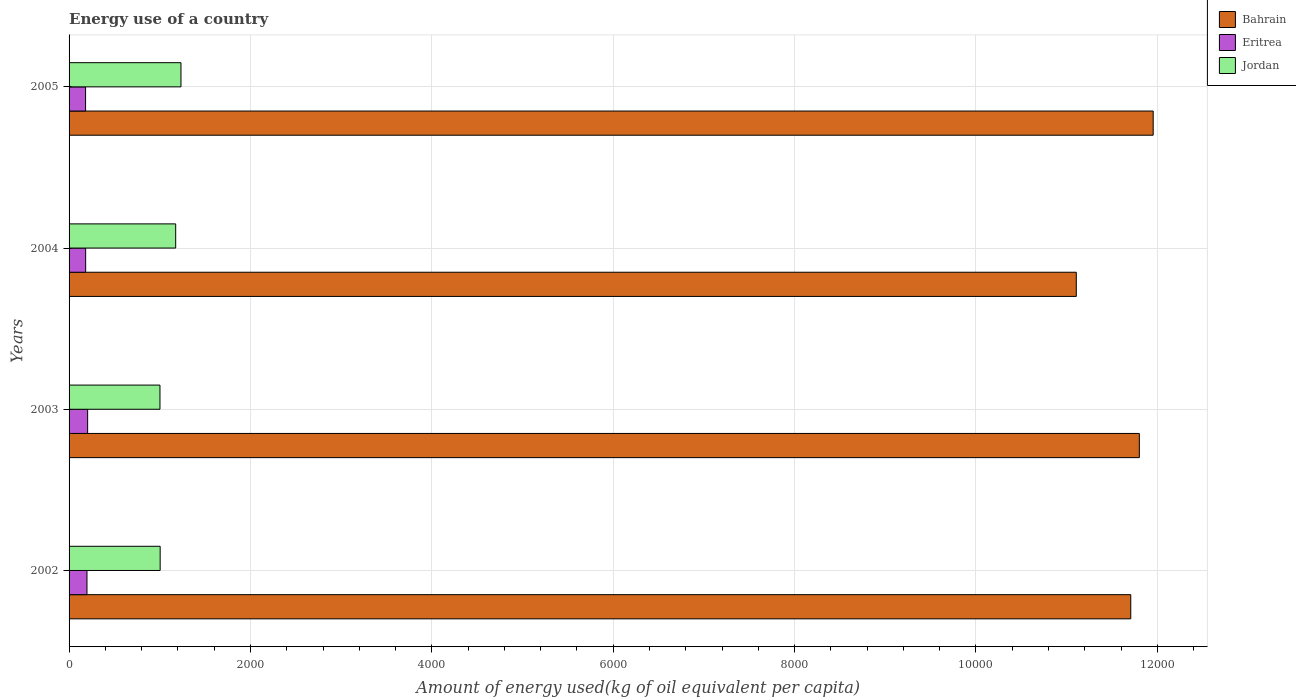How many groups of bars are there?
Your response must be concise. 4. Are the number of bars per tick equal to the number of legend labels?
Make the answer very short. Yes. Are the number of bars on each tick of the Y-axis equal?
Provide a succinct answer. Yes. How many bars are there on the 2nd tick from the bottom?
Make the answer very short. 3. What is the amount of energy used in in Bahrain in 2005?
Provide a short and direct response. 1.20e+04. Across all years, what is the maximum amount of energy used in in Jordan?
Your response must be concise. 1233.95. Across all years, what is the minimum amount of energy used in in Eritrea?
Your answer should be compact. 182.02. In which year was the amount of energy used in in Bahrain minimum?
Make the answer very short. 2004. What is the total amount of energy used in in Eritrea in the graph?
Your response must be concise. 767.22. What is the difference between the amount of energy used in in Eritrea in 2002 and that in 2005?
Offer a very short reply. 15.53. What is the difference between the amount of energy used in in Eritrea in 2004 and the amount of energy used in in Bahrain in 2003?
Offer a very short reply. -1.16e+04. What is the average amount of energy used in in Eritrea per year?
Make the answer very short. 191.81. In the year 2004, what is the difference between the amount of energy used in in Jordan and amount of energy used in in Bahrain?
Give a very brief answer. -9931.05. What is the ratio of the amount of energy used in in Jordan in 2002 to that in 2003?
Offer a terse response. 1. Is the amount of energy used in in Eritrea in 2002 less than that in 2003?
Offer a very short reply. Yes. Is the difference between the amount of energy used in in Jordan in 2003 and 2005 greater than the difference between the amount of energy used in in Bahrain in 2003 and 2005?
Give a very brief answer. No. What is the difference between the highest and the second highest amount of energy used in in Jordan?
Provide a succinct answer. 58.27. What is the difference between the highest and the lowest amount of energy used in in Jordan?
Ensure brevity in your answer.  231.67. In how many years, is the amount of energy used in in Bahrain greater than the average amount of energy used in in Bahrain taken over all years?
Your response must be concise. 3. Is the sum of the amount of energy used in in Bahrain in 2003 and 2004 greater than the maximum amount of energy used in in Jordan across all years?
Ensure brevity in your answer.  Yes. What does the 3rd bar from the top in 2004 represents?
Offer a terse response. Bahrain. What does the 2nd bar from the bottom in 2003 represents?
Ensure brevity in your answer.  Eritrea. Where does the legend appear in the graph?
Offer a very short reply. Top right. What is the title of the graph?
Provide a succinct answer. Energy use of a country. Does "Guatemala" appear as one of the legend labels in the graph?
Offer a very short reply. No. What is the label or title of the X-axis?
Your answer should be compact. Amount of energy used(kg of oil equivalent per capita). What is the Amount of energy used(kg of oil equivalent per capita) of Bahrain in 2002?
Give a very brief answer. 1.17e+04. What is the Amount of energy used(kg of oil equivalent per capita) in Eritrea in 2002?
Offer a terse response. 197.55. What is the Amount of energy used(kg of oil equivalent per capita) of Jordan in 2002?
Offer a terse response. 1004.46. What is the Amount of energy used(kg of oil equivalent per capita) in Bahrain in 2003?
Offer a very short reply. 1.18e+04. What is the Amount of energy used(kg of oil equivalent per capita) of Eritrea in 2003?
Your answer should be compact. 204.73. What is the Amount of energy used(kg of oil equivalent per capita) of Jordan in 2003?
Keep it short and to the point. 1002.28. What is the Amount of energy used(kg of oil equivalent per capita) in Bahrain in 2004?
Provide a short and direct response. 1.11e+04. What is the Amount of energy used(kg of oil equivalent per capita) of Eritrea in 2004?
Provide a succinct answer. 182.92. What is the Amount of energy used(kg of oil equivalent per capita) in Jordan in 2004?
Your response must be concise. 1175.68. What is the Amount of energy used(kg of oil equivalent per capita) in Bahrain in 2005?
Offer a terse response. 1.20e+04. What is the Amount of energy used(kg of oil equivalent per capita) of Eritrea in 2005?
Make the answer very short. 182.02. What is the Amount of energy used(kg of oil equivalent per capita) in Jordan in 2005?
Offer a very short reply. 1233.95. Across all years, what is the maximum Amount of energy used(kg of oil equivalent per capita) of Bahrain?
Ensure brevity in your answer.  1.20e+04. Across all years, what is the maximum Amount of energy used(kg of oil equivalent per capita) of Eritrea?
Make the answer very short. 204.73. Across all years, what is the maximum Amount of energy used(kg of oil equivalent per capita) of Jordan?
Your response must be concise. 1233.95. Across all years, what is the minimum Amount of energy used(kg of oil equivalent per capita) of Bahrain?
Offer a very short reply. 1.11e+04. Across all years, what is the minimum Amount of energy used(kg of oil equivalent per capita) in Eritrea?
Your answer should be very brief. 182.02. Across all years, what is the minimum Amount of energy used(kg of oil equivalent per capita) of Jordan?
Offer a terse response. 1002.28. What is the total Amount of energy used(kg of oil equivalent per capita) in Bahrain in the graph?
Give a very brief answer. 4.66e+04. What is the total Amount of energy used(kg of oil equivalent per capita) of Eritrea in the graph?
Give a very brief answer. 767.22. What is the total Amount of energy used(kg of oil equivalent per capita) in Jordan in the graph?
Offer a terse response. 4416.38. What is the difference between the Amount of energy used(kg of oil equivalent per capita) in Bahrain in 2002 and that in 2003?
Give a very brief answer. -94.74. What is the difference between the Amount of energy used(kg of oil equivalent per capita) in Eritrea in 2002 and that in 2003?
Give a very brief answer. -7.18. What is the difference between the Amount of energy used(kg of oil equivalent per capita) in Jordan in 2002 and that in 2003?
Offer a terse response. 2.18. What is the difference between the Amount of energy used(kg of oil equivalent per capita) of Bahrain in 2002 and that in 2004?
Your response must be concise. 600.51. What is the difference between the Amount of energy used(kg of oil equivalent per capita) of Eritrea in 2002 and that in 2004?
Keep it short and to the point. 14.63. What is the difference between the Amount of energy used(kg of oil equivalent per capita) of Jordan in 2002 and that in 2004?
Offer a very short reply. -171.22. What is the difference between the Amount of energy used(kg of oil equivalent per capita) of Bahrain in 2002 and that in 2005?
Keep it short and to the point. -247.37. What is the difference between the Amount of energy used(kg of oil equivalent per capita) in Eritrea in 2002 and that in 2005?
Your response must be concise. 15.53. What is the difference between the Amount of energy used(kg of oil equivalent per capita) in Jordan in 2002 and that in 2005?
Your response must be concise. -229.49. What is the difference between the Amount of energy used(kg of oil equivalent per capita) of Bahrain in 2003 and that in 2004?
Provide a succinct answer. 695.25. What is the difference between the Amount of energy used(kg of oil equivalent per capita) of Eritrea in 2003 and that in 2004?
Your answer should be very brief. 21.81. What is the difference between the Amount of energy used(kg of oil equivalent per capita) in Jordan in 2003 and that in 2004?
Offer a terse response. -173.4. What is the difference between the Amount of energy used(kg of oil equivalent per capita) of Bahrain in 2003 and that in 2005?
Provide a succinct answer. -152.63. What is the difference between the Amount of energy used(kg of oil equivalent per capita) of Eritrea in 2003 and that in 2005?
Give a very brief answer. 22.72. What is the difference between the Amount of energy used(kg of oil equivalent per capita) of Jordan in 2003 and that in 2005?
Offer a very short reply. -231.67. What is the difference between the Amount of energy used(kg of oil equivalent per capita) of Bahrain in 2004 and that in 2005?
Keep it short and to the point. -847.88. What is the difference between the Amount of energy used(kg of oil equivalent per capita) of Eritrea in 2004 and that in 2005?
Your response must be concise. 0.9. What is the difference between the Amount of energy used(kg of oil equivalent per capita) of Jordan in 2004 and that in 2005?
Your answer should be compact. -58.27. What is the difference between the Amount of energy used(kg of oil equivalent per capita) in Bahrain in 2002 and the Amount of energy used(kg of oil equivalent per capita) in Eritrea in 2003?
Make the answer very short. 1.15e+04. What is the difference between the Amount of energy used(kg of oil equivalent per capita) of Bahrain in 2002 and the Amount of energy used(kg of oil equivalent per capita) of Jordan in 2003?
Keep it short and to the point. 1.07e+04. What is the difference between the Amount of energy used(kg of oil equivalent per capita) of Eritrea in 2002 and the Amount of energy used(kg of oil equivalent per capita) of Jordan in 2003?
Provide a short and direct response. -804.73. What is the difference between the Amount of energy used(kg of oil equivalent per capita) of Bahrain in 2002 and the Amount of energy used(kg of oil equivalent per capita) of Eritrea in 2004?
Give a very brief answer. 1.15e+04. What is the difference between the Amount of energy used(kg of oil equivalent per capita) in Bahrain in 2002 and the Amount of energy used(kg of oil equivalent per capita) in Jordan in 2004?
Keep it short and to the point. 1.05e+04. What is the difference between the Amount of energy used(kg of oil equivalent per capita) in Eritrea in 2002 and the Amount of energy used(kg of oil equivalent per capita) in Jordan in 2004?
Provide a short and direct response. -978.13. What is the difference between the Amount of energy used(kg of oil equivalent per capita) of Bahrain in 2002 and the Amount of energy used(kg of oil equivalent per capita) of Eritrea in 2005?
Make the answer very short. 1.15e+04. What is the difference between the Amount of energy used(kg of oil equivalent per capita) in Bahrain in 2002 and the Amount of energy used(kg of oil equivalent per capita) in Jordan in 2005?
Your answer should be compact. 1.05e+04. What is the difference between the Amount of energy used(kg of oil equivalent per capita) of Eritrea in 2002 and the Amount of energy used(kg of oil equivalent per capita) of Jordan in 2005?
Give a very brief answer. -1036.4. What is the difference between the Amount of energy used(kg of oil equivalent per capita) in Bahrain in 2003 and the Amount of energy used(kg of oil equivalent per capita) in Eritrea in 2004?
Your response must be concise. 1.16e+04. What is the difference between the Amount of energy used(kg of oil equivalent per capita) in Bahrain in 2003 and the Amount of energy used(kg of oil equivalent per capita) in Jordan in 2004?
Ensure brevity in your answer.  1.06e+04. What is the difference between the Amount of energy used(kg of oil equivalent per capita) in Eritrea in 2003 and the Amount of energy used(kg of oil equivalent per capita) in Jordan in 2004?
Provide a short and direct response. -970.95. What is the difference between the Amount of energy used(kg of oil equivalent per capita) in Bahrain in 2003 and the Amount of energy used(kg of oil equivalent per capita) in Eritrea in 2005?
Your answer should be very brief. 1.16e+04. What is the difference between the Amount of energy used(kg of oil equivalent per capita) in Bahrain in 2003 and the Amount of energy used(kg of oil equivalent per capita) in Jordan in 2005?
Provide a succinct answer. 1.06e+04. What is the difference between the Amount of energy used(kg of oil equivalent per capita) of Eritrea in 2003 and the Amount of energy used(kg of oil equivalent per capita) of Jordan in 2005?
Give a very brief answer. -1029.22. What is the difference between the Amount of energy used(kg of oil equivalent per capita) in Bahrain in 2004 and the Amount of energy used(kg of oil equivalent per capita) in Eritrea in 2005?
Offer a terse response. 1.09e+04. What is the difference between the Amount of energy used(kg of oil equivalent per capita) in Bahrain in 2004 and the Amount of energy used(kg of oil equivalent per capita) in Jordan in 2005?
Keep it short and to the point. 9872.78. What is the difference between the Amount of energy used(kg of oil equivalent per capita) in Eritrea in 2004 and the Amount of energy used(kg of oil equivalent per capita) in Jordan in 2005?
Your answer should be very brief. -1051.03. What is the average Amount of energy used(kg of oil equivalent per capita) in Bahrain per year?
Offer a very short reply. 1.16e+04. What is the average Amount of energy used(kg of oil equivalent per capita) of Eritrea per year?
Offer a terse response. 191.81. What is the average Amount of energy used(kg of oil equivalent per capita) in Jordan per year?
Offer a terse response. 1104.09. In the year 2002, what is the difference between the Amount of energy used(kg of oil equivalent per capita) in Bahrain and Amount of energy used(kg of oil equivalent per capita) in Eritrea?
Provide a succinct answer. 1.15e+04. In the year 2002, what is the difference between the Amount of energy used(kg of oil equivalent per capita) in Bahrain and Amount of energy used(kg of oil equivalent per capita) in Jordan?
Offer a very short reply. 1.07e+04. In the year 2002, what is the difference between the Amount of energy used(kg of oil equivalent per capita) in Eritrea and Amount of energy used(kg of oil equivalent per capita) in Jordan?
Your response must be concise. -806.91. In the year 2003, what is the difference between the Amount of energy used(kg of oil equivalent per capita) of Bahrain and Amount of energy used(kg of oil equivalent per capita) of Eritrea?
Your answer should be very brief. 1.16e+04. In the year 2003, what is the difference between the Amount of energy used(kg of oil equivalent per capita) in Bahrain and Amount of energy used(kg of oil equivalent per capita) in Jordan?
Keep it short and to the point. 1.08e+04. In the year 2003, what is the difference between the Amount of energy used(kg of oil equivalent per capita) of Eritrea and Amount of energy used(kg of oil equivalent per capita) of Jordan?
Provide a short and direct response. -797.55. In the year 2004, what is the difference between the Amount of energy used(kg of oil equivalent per capita) in Bahrain and Amount of energy used(kg of oil equivalent per capita) in Eritrea?
Your response must be concise. 1.09e+04. In the year 2004, what is the difference between the Amount of energy used(kg of oil equivalent per capita) of Bahrain and Amount of energy used(kg of oil equivalent per capita) of Jordan?
Provide a short and direct response. 9931.05. In the year 2004, what is the difference between the Amount of energy used(kg of oil equivalent per capita) in Eritrea and Amount of energy used(kg of oil equivalent per capita) in Jordan?
Your answer should be very brief. -992.76. In the year 2005, what is the difference between the Amount of energy used(kg of oil equivalent per capita) of Bahrain and Amount of energy used(kg of oil equivalent per capita) of Eritrea?
Ensure brevity in your answer.  1.18e+04. In the year 2005, what is the difference between the Amount of energy used(kg of oil equivalent per capita) in Bahrain and Amount of energy used(kg of oil equivalent per capita) in Jordan?
Offer a very short reply. 1.07e+04. In the year 2005, what is the difference between the Amount of energy used(kg of oil equivalent per capita) in Eritrea and Amount of energy used(kg of oil equivalent per capita) in Jordan?
Provide a succinct answer. -1051.93. What is the ratio of the Amount of energy used(kg of oil equivalent per capita) of Bahrain in 2002 to that in 2003?
Keep it short and to the point. 0.99. What is the ratio of the Amount of energy used(kg of oil equivalent per capita) of Eritrea in 2002 to that in 2003?
Your answer should be very brief. 0.96. What is the ratio of the Amount of energy used(kg of oil equivalent per capita) of Jordan in 2002 to that in 2003?
Offer a terse response. 1. What is the ratio of the Amount of energy used(kg of oil equivalent per capita) in Bahrain in 2002 to that in 2004?
Ensure brevity in your answer.  1.05. What is the ratio of the Amount of energy used(kg of oil equivalent per capita) in Eritrea in 2002 to that in 2004?
Your response must be concise. 1.08. What is the ratio of the Amount of energy used(kg of oil equivalent per capita) of Jordan in 2002 to that in 2004?
Your answer should be compact. 0.85. What is the ratio of the Amount of energy used(kg of oil equivalent per capita) of Bahrain in 2002 to that in 2005?
Your answer should be very brief. 0.98. What is the ratio of the Amount of energy used(kg of oil equivalent per capita) in Eritrea in 2002 to that in 2005?
Provide a short and direct response. 1.09. What is the ratio of the Amount of energy used(kg of oil equivalent per capita) of Jordan in 2002 to that in 2005?
Ensure brevity in your answer.  0.81. What is the ratio of the Amount of energy used(kg of oil equivalent per capita) in Bahrain in 2003 to that in 2004?
Provide a short and direct response. 1.06. What is the ratio of the Amount of energy used(kg of oil equivalent per capita) of Eritrea in 2003 to that in 2004?
Your answer should be very brief. 1.12. What is the ratio of the Amount of energy used(kg of oil equivalent per capita) in Jordan in 2003 to that in 2004?
Keep it short and to the point. 0.85. What is the ratio of the Amount of energy used(kg of oil equivalent per capita) of Bahrain in 2003 to that in 2005?
Your answer should be very brief. 0.99. What is the ratio of the Amount of energy used(kg of oil equivalent per capita) in Eritrea in 2003 to that in 2005?
Offer a terse response. 1.12. What is the ratio of the Amount of energy used(kg of oil equivalent per capita) in Jordan in 2003 to that in 2005?
Ensure brevity in your answer.  0.81. What is the ratio of the Amount of energy used(kg of oil equivalent per capita) of Bahrain in 2004 to that in 2005?
Keep it short and to the point. 0.93. What is the ratio of the Amount of energy used(kg of oil equivalent per capita) in Jordan in 2004 to that in 2005?
Your response must be concise. 0.95. What is the difference between the highest and the second highest Amount of energy used(kg of oil equivalent per capita) in Bahrain?
Your answer should be very brief. 152.63. What is the difference between the highest and the second highest Amount of energy used(kg of oil equivalent per capita) in Eritrea?
Your response must be concise. 7.18. What is the difference between the highest and the second highest Amount of energy used(kg of oil equivalent per capita) in Jordan?
Make the answer very short. 58.27. What is the difference between the highest and the lowest Amount of energy used(kg of oil equivalent per capita) in Bahrain?
Offer a very short reply. 847.88. What is the difference between the highest and the lowest Amount of energy used(kg of oil equivalent per capita) of Eritrea?
Make the answer very short. 22.72. What is the difference between the highest and the lowest Amount of energy used(kg of oil equivalent per capita) in Jordan?
Make the answer very short. 231.67. 